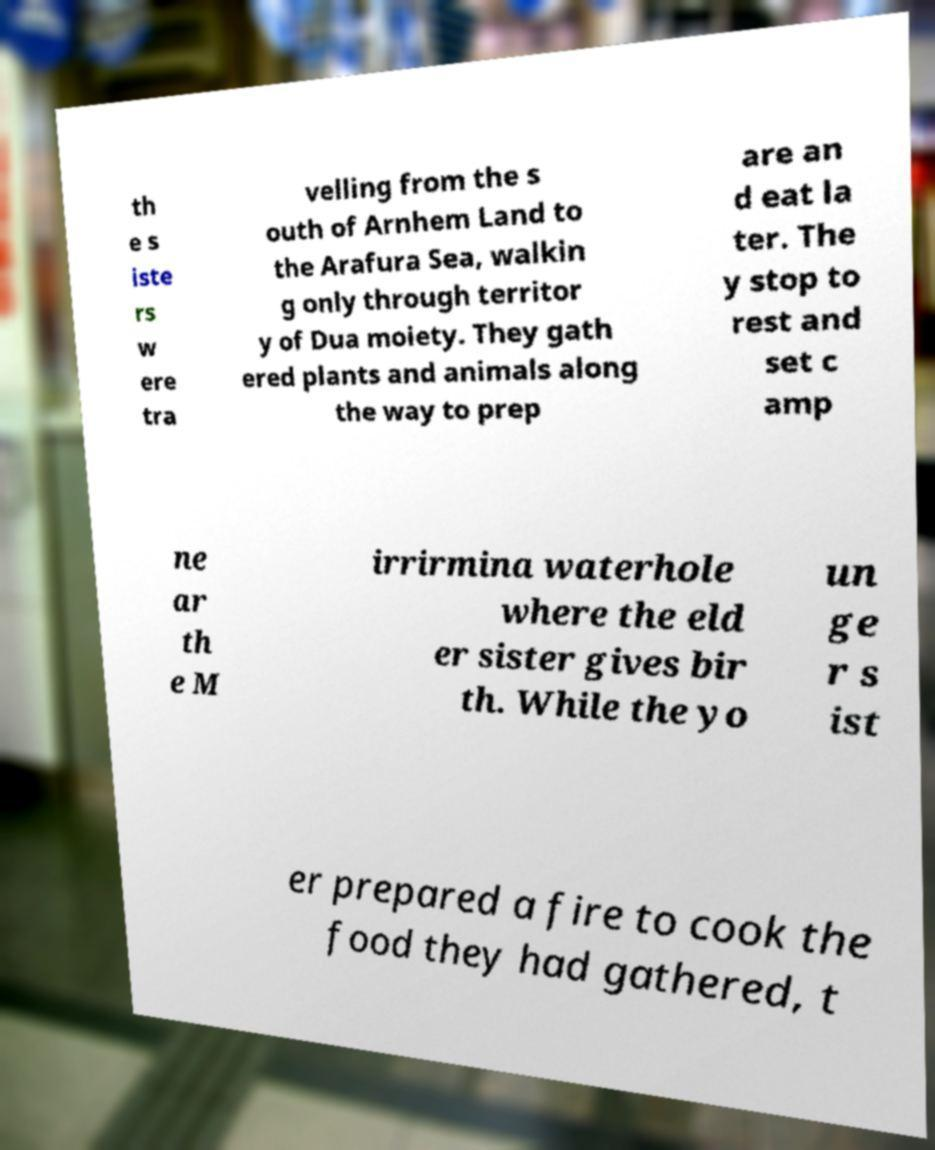For documentation purposes, I need the text within this image transcribed. Could you provide that? th e s iste rs w ere tra velling from the s outh of Arnhem Land to the Arafura Sea, walkin g only through territor y of Dua moiety. They gath ered plants and animals along the way to prep are an d eat la ter. The y stop to rest and set c amp ne ar th e M irrirmina waterhole where the eld er sister gives bir th. While the yo un ge r s ist er prepared a fire to cook the food they had gathered, t 